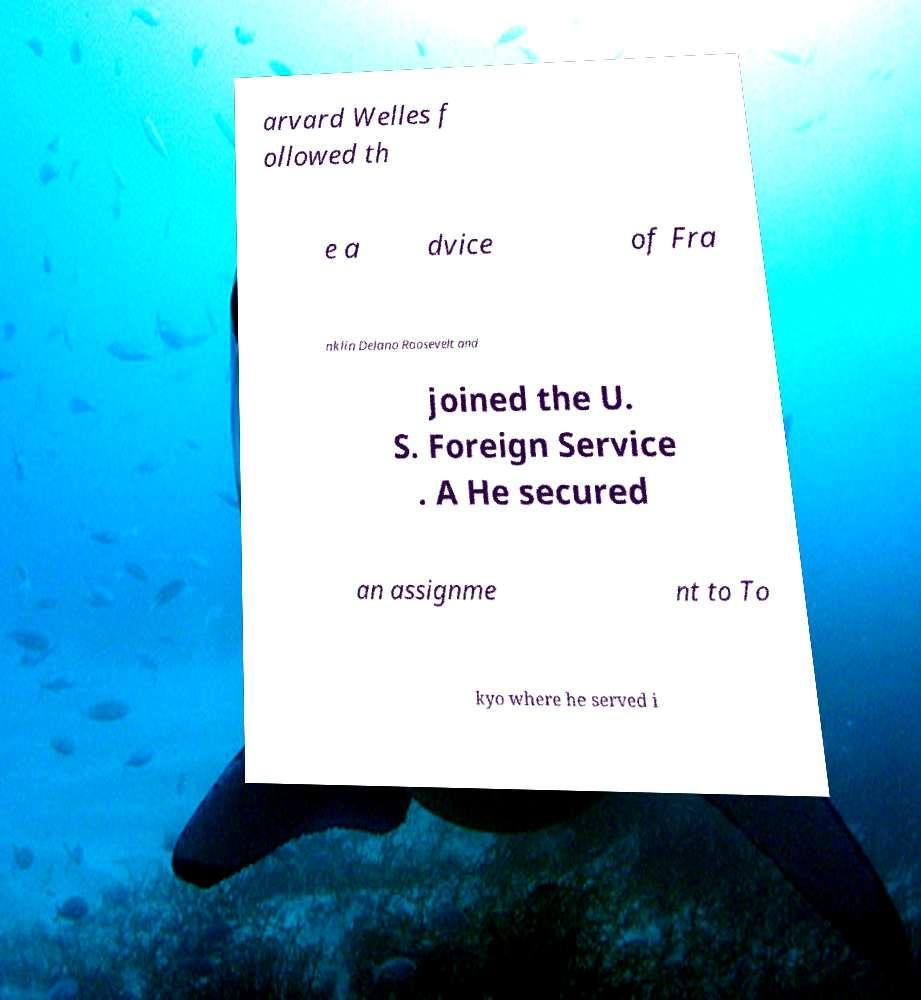Please read and relay the text visible in this image. What does it say? arvard Welles f ollowed th e a dvice of Fra nklin Delano Roosevelt and joined the U. S. Foreign Service . A He secured an assignme nt to To kyo where he served i 